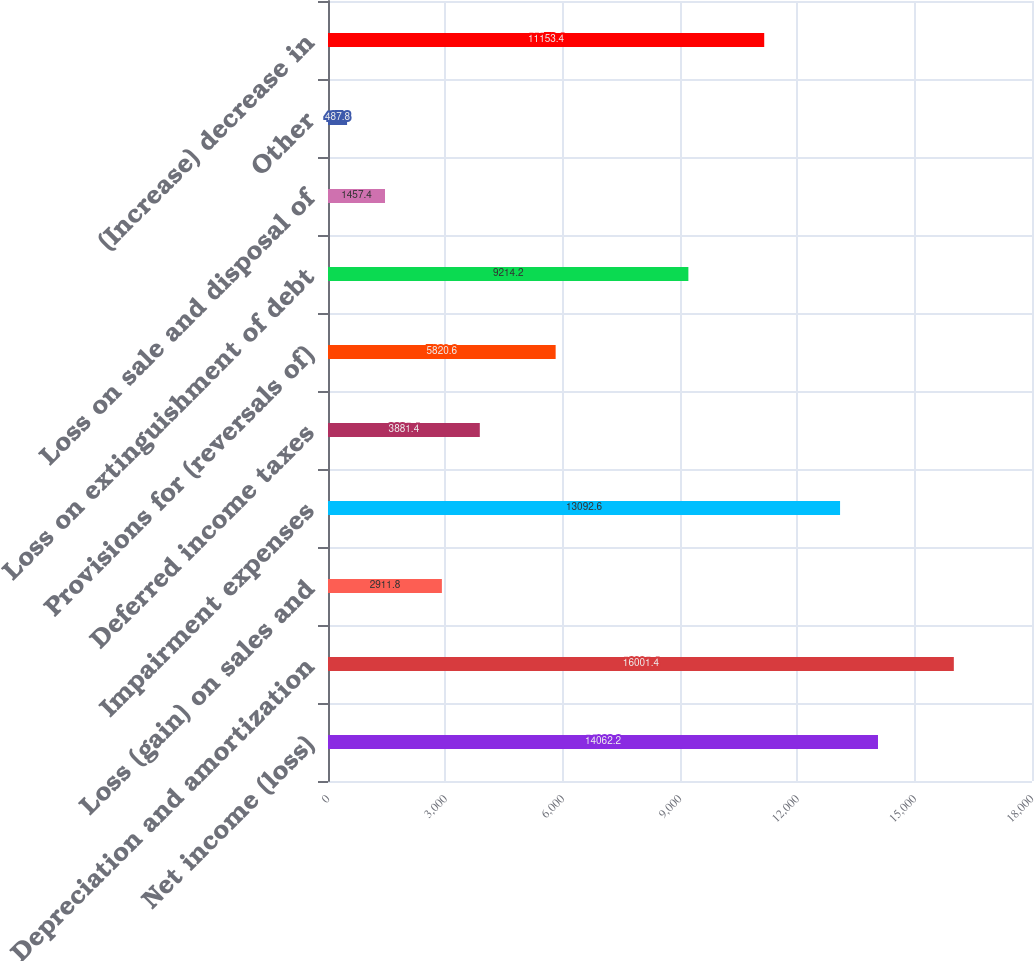<chart> <loc_0><loc_0><loc_500><loc_500><bar_chart><fcel>Net income (loss)<fcel>Depreciation and amortization<fcel>Loss (gain) on sales and<fcel>Impairment expenses<fcel>Deferred income taxes<fcel>Provisions for (reversals of)<fcel>Loss on extinguishment of debt<fcel>Loss on sale and disposal of<fcel>Other<fcel>(Increase) decrease in<nl><fcel>14062.2<fcel>16001.4<fcel>2911.8<fcel>13092.6<fcel>3881.4<fcel>5820.6<fcel>9214.2<fcel>1457.4<fcel>487.8<fcel>11153.4<nl></chart> 